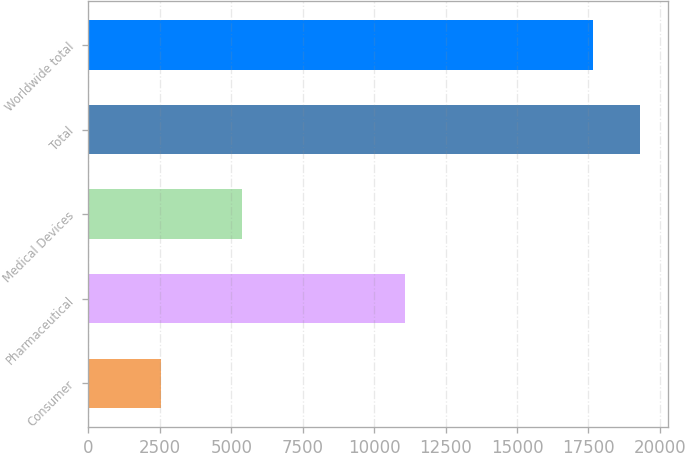Convert chart to OTSL. <chart><loc_0><loc_0><loc_500><loc_500><bar_chart><fcel>Consumer<fcel>Pharmaceutical<fcel>Medical Devices<fcel>Total<fcel>Worldwide total<nl><fcel>2524<fcel>11083<fcel>5392<fcel>19320.5<fcel>17673<nl></chart> 